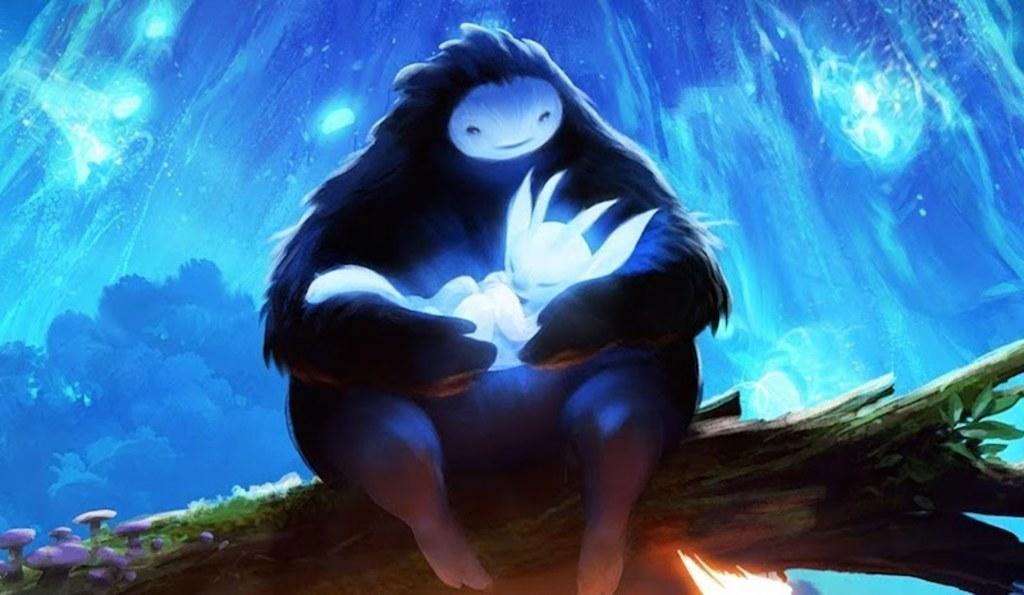What type of image is being described? The image is animated. What can be seen in the foreground of the image? There is an alien-like figure in the foreground. How would you describe the background of the image? The background of the image is colored. What type of corn can be seen growing in the background of the image? There is no corn present in the image; the background is simply colored. 